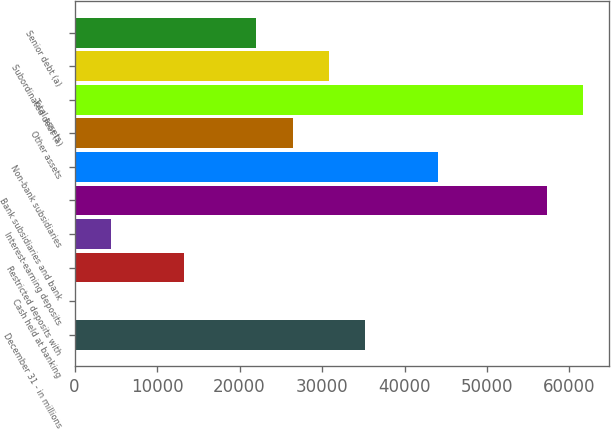Convert chart to OTSL. <chart><loc_0><loc_0><loc_500><loc_500><bar_chart><fcel>December 31 - in millions<fcel>Cash held at banking<fcel>Restricted deposits with<fcel>Interest-earning deposits<fcel>Bank subsidiaries and bank<fcel>Non-bank subsidiaries<fcel>Other assets<fcel>Total assets<fcel>Subordinated debt (a)<fcel>Senior debt (a)<nl><fcel>35232.4<fcel>2<fcel>13213.4<fcel>4405.8<fcel>57251.4<fcel>44040<fcel>26424.8<fcel>61655.2<fcel>30828.6<fcel>22021<nl></chart> 